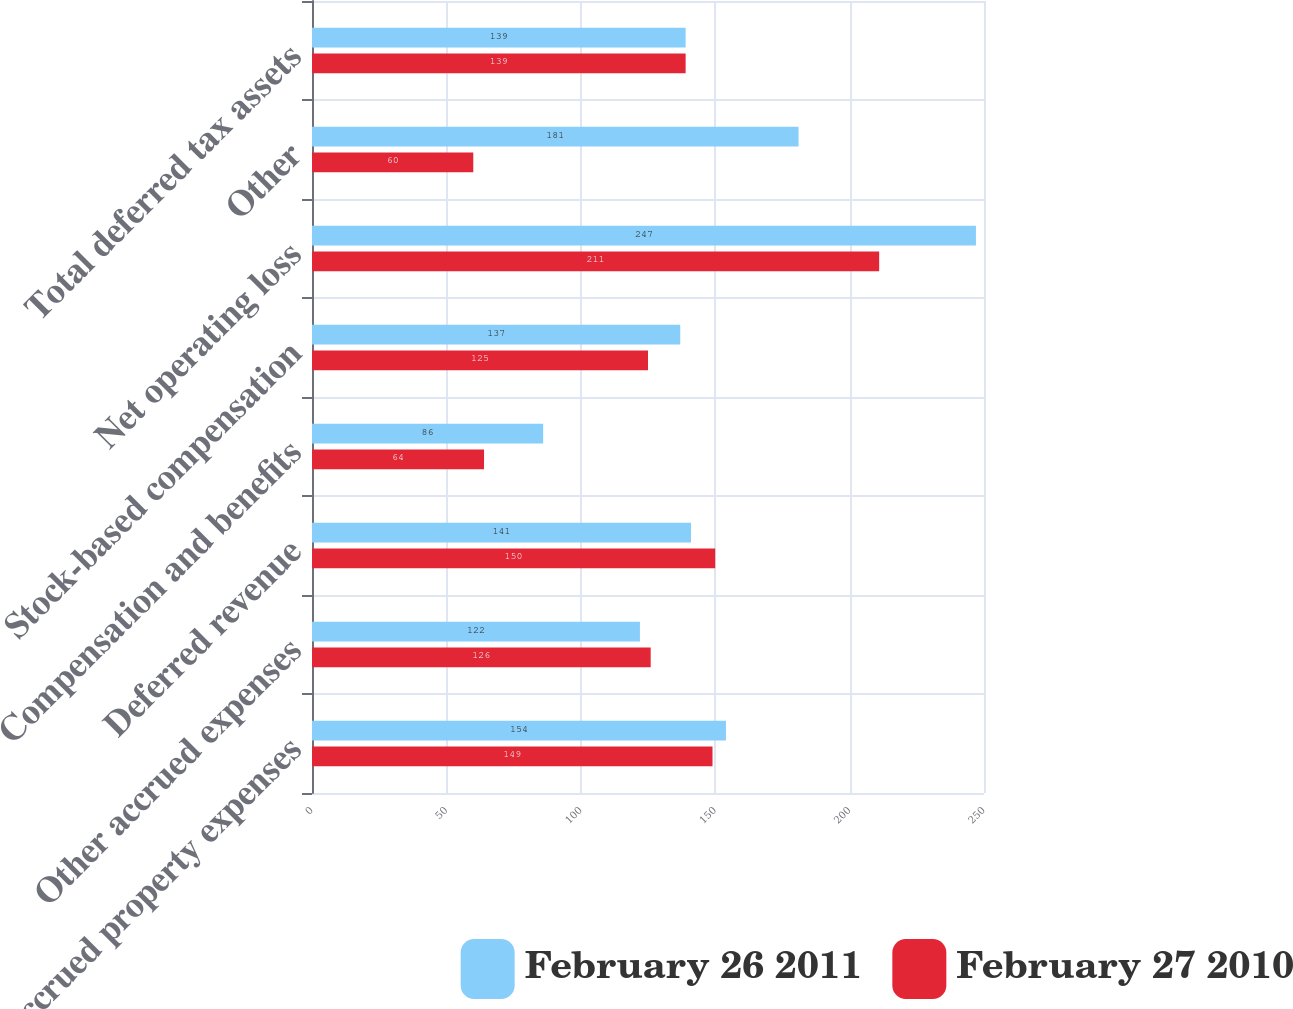<chart> <loc_0><loc_0><loc_500><loc_500><stacked_bar_chart><ecel><fcel>Accrued property expenses<fcel>Other accrued expenses<fcel>Deferred revenue<fcel>Compensation and benefits<fcel>Stock-based compensation<fcel>Net operating loss<fcel>Other<fcel>Total deferred tax assets<nl><fcel>February 26 2011<fcel>154<fcel>122<fcel>141<fcel>86<fcel>137<fcel>247<fcel>181<fcel>139<nl><fcel>February 27 2010<fcel>149<fcel>126<fcel>150<fcel>64<fcel>125<fcel>211<fcel>60<fcel>139<nl></chart> 